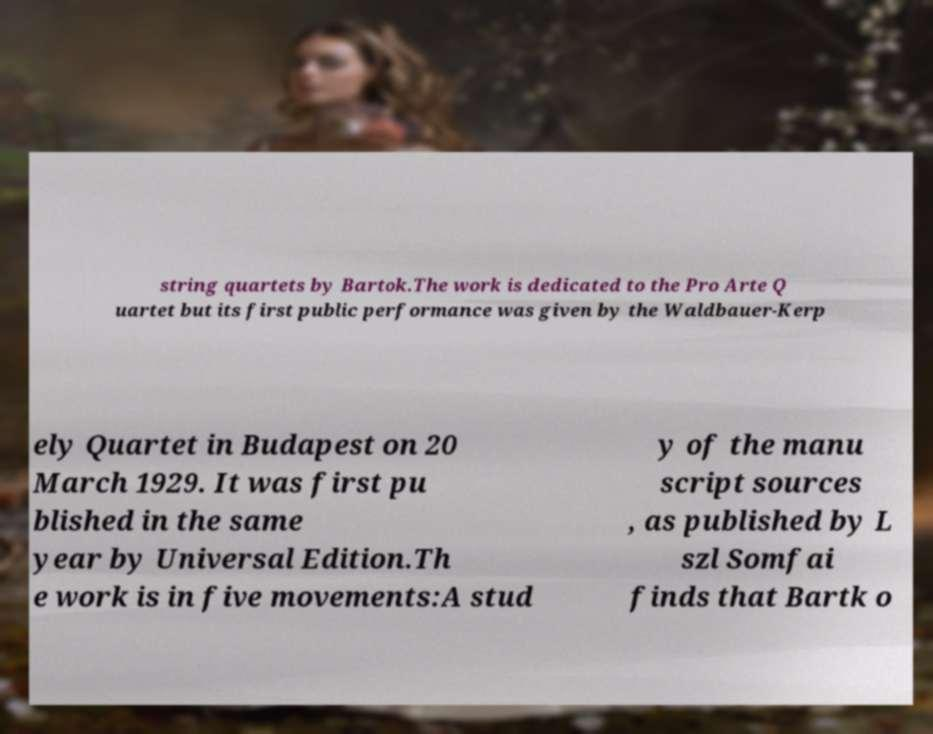Please identify and transcribe the text found in this image. string quartets by Bartok.The work is dedicated to the Pro Arte Q uartet but its first public performance was given by the Waldbauer-Kerp ely Quartet in Budapest on 20 March 1929. It was first pu blished in the same year by Universal Edition.Th e work is in five movements:A stud y of the manu script sources , as published by L szl Somfai finds that Bartk o 